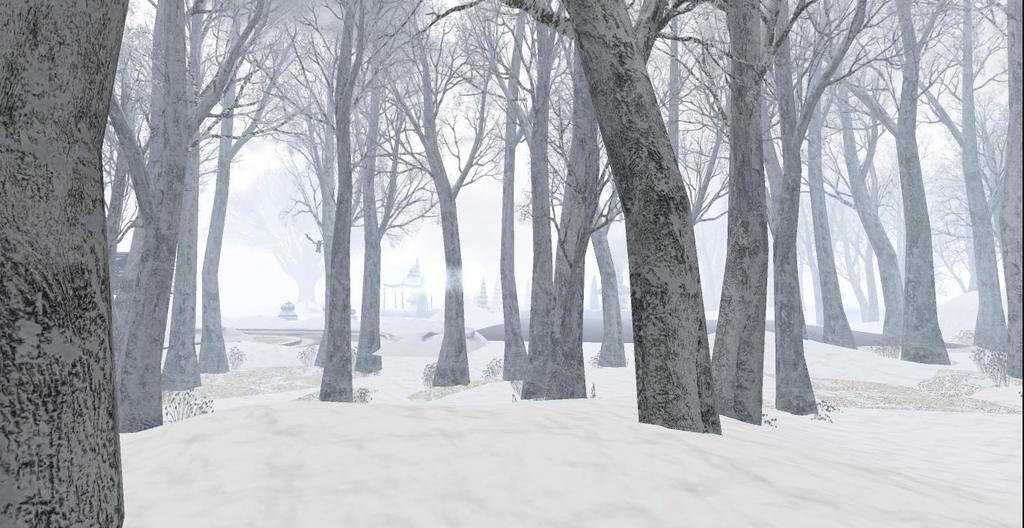What is covering the ground at the bottom of the image? There is snow on the ground at the bottom of the image. What type of vegetation can be seen in the image? There are many trees in the image. How does the writer contribute to the earthquake in the image? There is no writer or earthquake present in the image. 